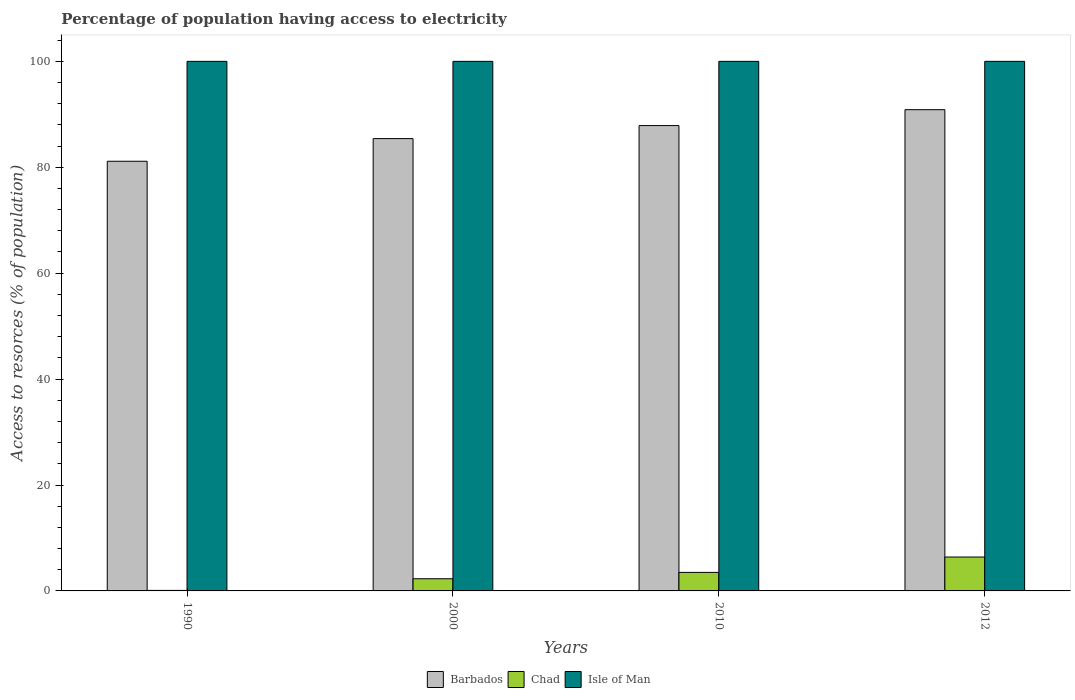How many groups of bars are there?
Offer a terse response. 4. Are the number of bars per tick equal to the number of legend labels?
Your answer should be compact. Yes. Are the number of bars on each tick of the X-axis equal?
Offer a terse response. Yes. How many bars are there on the 4th tick from the right?
Ensure brevity in your answer.  3. What is the percentage of population having access to electricity in Barbados in 2000?
Your answer should be compact. 85.41. Across all years, what is the minimum percentage of population having access to electricity in Isle of Man?
Provide a short and direct response. 100. In which year was the percentage of population having access to electricity in Barbados maximum?
Your answer should be compact. 2012. In which year was the percentage of population having access to electricity in Chad minimum?
Make the answer very short. 1990. What is the total percentage of population having access to electricity in Barbados in the graph?
Offer a terse response. 345.3. What is the difference between the percentage of population having access to electricity in Barbados in 2010 and the percentage of population having access to electricity in Isle of Man in 2012?
Offer a very short reply. -12.13. What is the average percentage of population having access to electricity in Chad per year?
Your answer should be very brief. 3.08. In the year 1990, what is the difference between the percentage of population having access to electricity in Isle of Man and percentage of population having access to electricity in Barbados?
Keep it short and to the point. 18.86. In how many years, is the percentage of population having access to electricity in Barbados greater than 68 %?
Give a very brief answer. 4. What is the ratio of the percentage of population having access to electricity in Isle of Man in 2000 to that in 2010?
Your response must be concise. 1. Is the percentage of population having access to electricity in Chad in 2000 less than that in 2010?
Offer a very short reply. Yes. Is the difference between the percentage of population having access to electricity in Isle of Man in 2000 and 2012 greater than the difference between the percentage of population having access to electricity in Barbados in 2000 and 2012?
Your response must be concise. Yes. What is the difference between the highest and the second highest percentage of population having access to electricity in Barbados?
Offer a terse response. 3. What is the difference between the highest and the lowest percentage of population having access to electricity in Barbados?
Your answer should be very brief. 9.74. What does the 3rd bar from the left in 1990 represents?
Ensure brevity in your answer.  Isle of Man. What does the 2nd bar from the right in 2000 represents?
Provide a short and direct response. Chad. Is it the case that in every year, the sum of the percentage of population having access to electricity in Chad and percentage of population having access to electricity in Barbados is greater than the percentage of population having access to electricity in Isle of Man?
Your answer should be very brief. No. How many bars are there?
Offer a terse response. 12. Are all the bars in the graph horizontal?
Your answer should be very brief. No. What is the difference between two consecutive major ticks on the Y-axis?
Offer a very short reply. 20. Does the graph contain any zero values?
Provide a succinct answer. No. Does the graph contain grids?
Your answer should be very brief. No. Where does the legend appear in the graph?
Provide a short and direct response. Bottom center. How many legend labels are there?
Provide a succinct answer. 3. What is the title of the graph?
Your answer should be very brief. Percentage of population having access to electricity. Does "Eritrea" appear as one of the legend labels in the graph?
Your answer should be compact. No. What is the label or title of the Y-axis?
Your answer should be very brief. Access to resorces (% of population). What is the Access to resorces (% of population) in Barbados in 1990?
Offer a terse response. 81.14. What is the Access to resorces (% of population) of Barbados in 2000?
Make the answer very short. 85.41. What is the Access to resorces (% of population) of Chad in 2000?
Offer a very short reply. 2.3. What is the Access to resorces (% of population) of Barbados in 2010?
Ensure brevity in your answer.  87.87. What is the Access to resorces (% of population) in Chad in 2010?
Provide a short and direct response. 3.5. What is the Access to resorces (% of population) in Barbados in 2012?
Keep it short and to the point. 90.88. What is the Access to resorces (% of population) of Chad in 2012?
Provide a short and direct response. 6.4. Across all years, what is the maximum Access to resorces (% of population) in Barbados?
Your answer should be very brief. 90.88. Across all years, what is the minimum Access to resorces (% of population) of Barbados?
Provide a succinct answer. 81.14. Across all years, what is the minimum Access to resorces (% of population) of Isle of Man?
Give a very brief answer. 100. What is the total Access to resorces (% of population) in Barbados in the graph?
Provide a succinct answer. 345.3. What is the difference between the Access to resorces (% of population) of Barbados in 1990 and that in 2000?
Offer a very short reply. -4.28. What is the difference between the Access to resorces (% of population) in Barbados in 1990 and that in 2010?
Keep it short and to the point. -6.74. What is the difference between the Access to resorces (% of population) in Isle of Man in 1990 and that in 2010?
Offer a terse response. 0. What is the difference between the Access to resorces (% of population) in Barbados in 1990 and that in 2012?
Your answer should be compact. -9.74. What is the difference between the Access to resorces (% of population) of Chad in 1990 and that in 2012?
Provide a short and direct response. -6.3. What is the difference between the Access to resorces (% of population) in Barbados in 2000 and that in 2010?
Offer a terse response. -2.46. What is the difference between the Access to resorces (% of population) in Chad in 2000 and that in 2010?
Your answer should be very brief. -1.2. What is the difference between the Access to resorces (% of population) of Barbados in 2000 and that in 2012?
Your answer should be compact. -5.46. What is the difference between the Access to resorces (% of population) of Chad in 2000 and that in 2012?
Give a very brief answer. -4.1. What is the difference between the Access to resorces (% of population) of Isle of Man in 2000 and that in 2012?
Your answer should be very brief. 0. What is the difference between the Access to resorces (% of population) of Barbados in 2010 and that in 2012?
Ensure brevity in your answer.  -3. What is the difference between the Access to resorces (% of population) of Chad in 2010 and that in 2012?
Provide a succinct answer. -2.9. What is the difference between the Access to resorces (% of population) in Isle of Man in 2010 and that in 2012?
Make the answer very short. 0. What is the difference between the Access to resorces (% of population) in Barbados in 1990 and the Access to resorces (% of population) in Chad in 2000?
Your answer should be compact. 78.84. What is the difference between the Access to resorces (% of population) of Barbados in 1990 and the Access to resorces (% of population) of Isle of Man in 2000?
Keep it short and to the point. -18.86. What is the difference between the Access to resorces (% of population) in Chad in 1990 and the Access to resorces (% of population) in Isle of Man in 2000?
Ensure brevity in your answer.  -99.9. What is the difference between the Access to resorces (% of population) of Barbados in 1990 and the Access to resorces (% of population) of Chad in 2010?
Your answer should be compact. 77.64. What is the difference between the Access to resorces (% of population) in Barbados in 1990 and the Access to resorces (% of population) in Isle of Man in 2010?
Keep it short and to the point. -18.86. What is the difference between the Access to resorces (% of population) in Chad in 1990 and the Access to resorces (% of population) in Isle of Man in 2010?
Offer a terse response. -99.9. What is the difference between the Access to resorces (% of population) of Barbados in 1990 and the Access to resorces (% of population) of Chad in 2012?
Ensure brevity in your answer.  74.74. What is the difference between the Access to resorces (% of population) in Barbados in 1990 and the Access to resorces (% of population) in Isle of Man in 2012?
Ensure brevity in your answer.  -18.86. What is the difference between the Access to resorces (% of population) of Chad in 1990 and the Access to resorces (% of population) of Isle of Man in 2012?
Provide a succinct answer. -99.9. What is the difference between the Access to resorces (% of population) of Barbados in 2000 and the Access to resorces (% of population) of Chad in 2010?
Provide a succinct answer. 81.91. What is the difference between the Access to resorces (% of population) in Barbados in 2000 and the Access to resorces (% of population) in Isle of Man in 2010?
Your answer should be compact. -14.59. What is the difference between the Access to resorces (% of population) of Chad in 2000 and the Access to resorces (% of population) of Isle of Man in 2010?
Your answer should be very brief. -97.7. What is the difference between the Access to resorces (% of population) in Barbados in 2000 and the Access to resorces (% of population) in Chad in 2012?
Make the answer very short. 79.01. What is the difference between the Access to resorces (% of population) of Barbados in 2000 and the Access to resorces (% of population) of Isle of Man in 2012?
Your answer should be very brief. -14.59. What is the difference between the Access to resorces (% of population) of Chad in 2000 and the Access to resorces (% of population) of Isle of Man in 2012?
Your answer should be compact. -97.7. What is the difference between the Access to resorces (% of population) of Barbados in 2010 and the Access to resorces (% of population) of Chad in 2012?
Ensure brevity in your answer.  81.47. What is the difference between the Access to resorces (% of population) of Barbados in 2010 and the Access to resorces (% of population) of Isle of Man in 2012?
Provide a succinct answer. -12.13. What is the difference between the Access to resorces (% of population) of Chad in 2010 and the Access to resorces (% of population) of Isle of Man in 2012?
Your answer should be compact. -96.5. What is the average Access to resorces (% of population) in Barbados per year?
Make the answer very short. 86.32. What is the average Access to resorces (% of population) in Chad per year?
Ensure brevity in your answer.  3.08. In the year 1990, what is the difference between the Access to resorces (% of population) of Barbados and Access to resorces (% of population) of Chad?
Provide a short and direct response. 81.04. In the year 1990, what is the difference between the Access to resorces (% of population) in Barbados and Access to resorces (% of population) in Isle of Man?
Give a very brief answer. -18.86. In the year 1990, what is the difference between the Access to resorces (% of population) in Chad and Access to resorces (% of population) in Isle of Man?
Provide a succinct answer. -99.9. In the year 2000, what is the difference between the Access to resorces (% of population) of Barbados and Access to resorces (% of population) of Chad?
Offer a very short reply. 83.11. In the year 2000, what is the difference between the Access to resorces (% of population) of Barbados and Access to resorces (% of population) of Isle of Man?
Your answer should be very brief. -14.59. In the year 2000, what is the difference between the Access to resorces (% of population) of Chad and Access to resorces (% of population) of Isle of Man?
Provide a short and direct response. -97.7. In the year 2010, what is the difference between the Access to resorces (% of population) in Barbados and Access to resorces (% of population) in Chad?
Offer a terse response. 84.37. In the year 2010, what is the difference between the Access to resorces (% of population) in Barbados and Access to resorces (% of population) in Isle of Man?
Keep it short and to the point. -12.13. In the year 2010, what is the difference between the Access to resorces (% of population) of Chad and Access to resorces (% of population) of Isle of Man?
Keep it short and to the point. -96.5. In the year 2012, what is the difference between the Access to resorces (% of population) in Barbados and Access to resorces (% of population) in Chad?
Keep it short and to the point. 84.48. In the year 2012, what is the difference between the Access to resorces (% of population) of Barbados and Access to resorces (% of population) of Isle of Man?
Your answer should be very brief. -9.12. In the year 2012, what is the difference between the Access to resorces (% of population) of Chad and Access to resorces (% of population) of Isle of Man?
Your response must be concise. -93.6. What is the ratio of the Access to resorces (% of population) of Barbados in 1990 to that in 2000?
Your answer should be very brief. 0.95. What is the ratio of the Access to resorces (% of population) of Chad in 1990 to that in 2000?
Your answer should be compact. 0.04. What is the ratio of the Access to resorces (% of population) of Isle of Man in 1990 to that in 2000?
Provide a short and direct response. 1. What is the ratio of the Access to resorces (% of population) of Barbados in 1990 to that in 2010?
Provide a succinct answer. 0.92. What is the ratio of the Access to resorces (% of population) in Chad in 1990 to that in 2010?
Offer a terse response. 0.03. What is the ratio of the Access to resorces (% of population) in Isle of Man in 1990 to that in 2010?
Your answer should be very brief. 1. What is the ratio of the Access to resorces (% of population) of Barbados in 1990 to that in 2012?
Provide a short and direct response. 0.89. What is the ratio of the Access to resorces (% of population) in Chad in 1990 to that in 2012?
Keep it short and to the point. 0.02. What is the ratio of the Access to resorces (% of population) in Barbados in 2000 to that in 2010?
Ensure brevity in your answer.  0.97. What is the ratio of the Access to resorces (% of population) of Chad in 2000 to that in 2010?
Ensure brevity in your answer.  0.66. What is the ratio of the Access to resorces (% of population) of Barbados in 2000 to that in 2012?
Your answer should be very brief. 0.94. What is the ratio of the Access to resorces (% of population) in Chad in 2000 to that in 2012?
Your answer should be very brief. 0.36. What is the ratio of the Access to resorces (% of population) of Barbados in 2010 to that in 2012?
Your response must be concise. 0.97. What is the ratio of the Access to resorces (% of population) of Chad in 2010 to that in 2012?
Keep it short and to the point. 0.55. What is the ratio of the Access to resorces (% of population) of Isle of Man in 2010 to that in 2012?
Provide a short and direct response. 1. What is the difference between the highest and the second highest Access to resorces (% of population) of Barbados?
Your response must be concise. 3. What is the difference between the highest and the second highest Access to resorces (% of population) in Isle of Man?
Your response must be concise. 0. What is the difference between the highest and the lowest Access to resorces (% of population) in Barbados?
Offer a very short reply. 9.74. What is the difference between the highest and the lowest Access to resorces (% of population) of Chad?
Ensure brevity in your answer.  6.3. What is the difference between the highest and the lowest Access to resorces (% of population) of Isle of Man?
Provide a succinct answer. 0. 